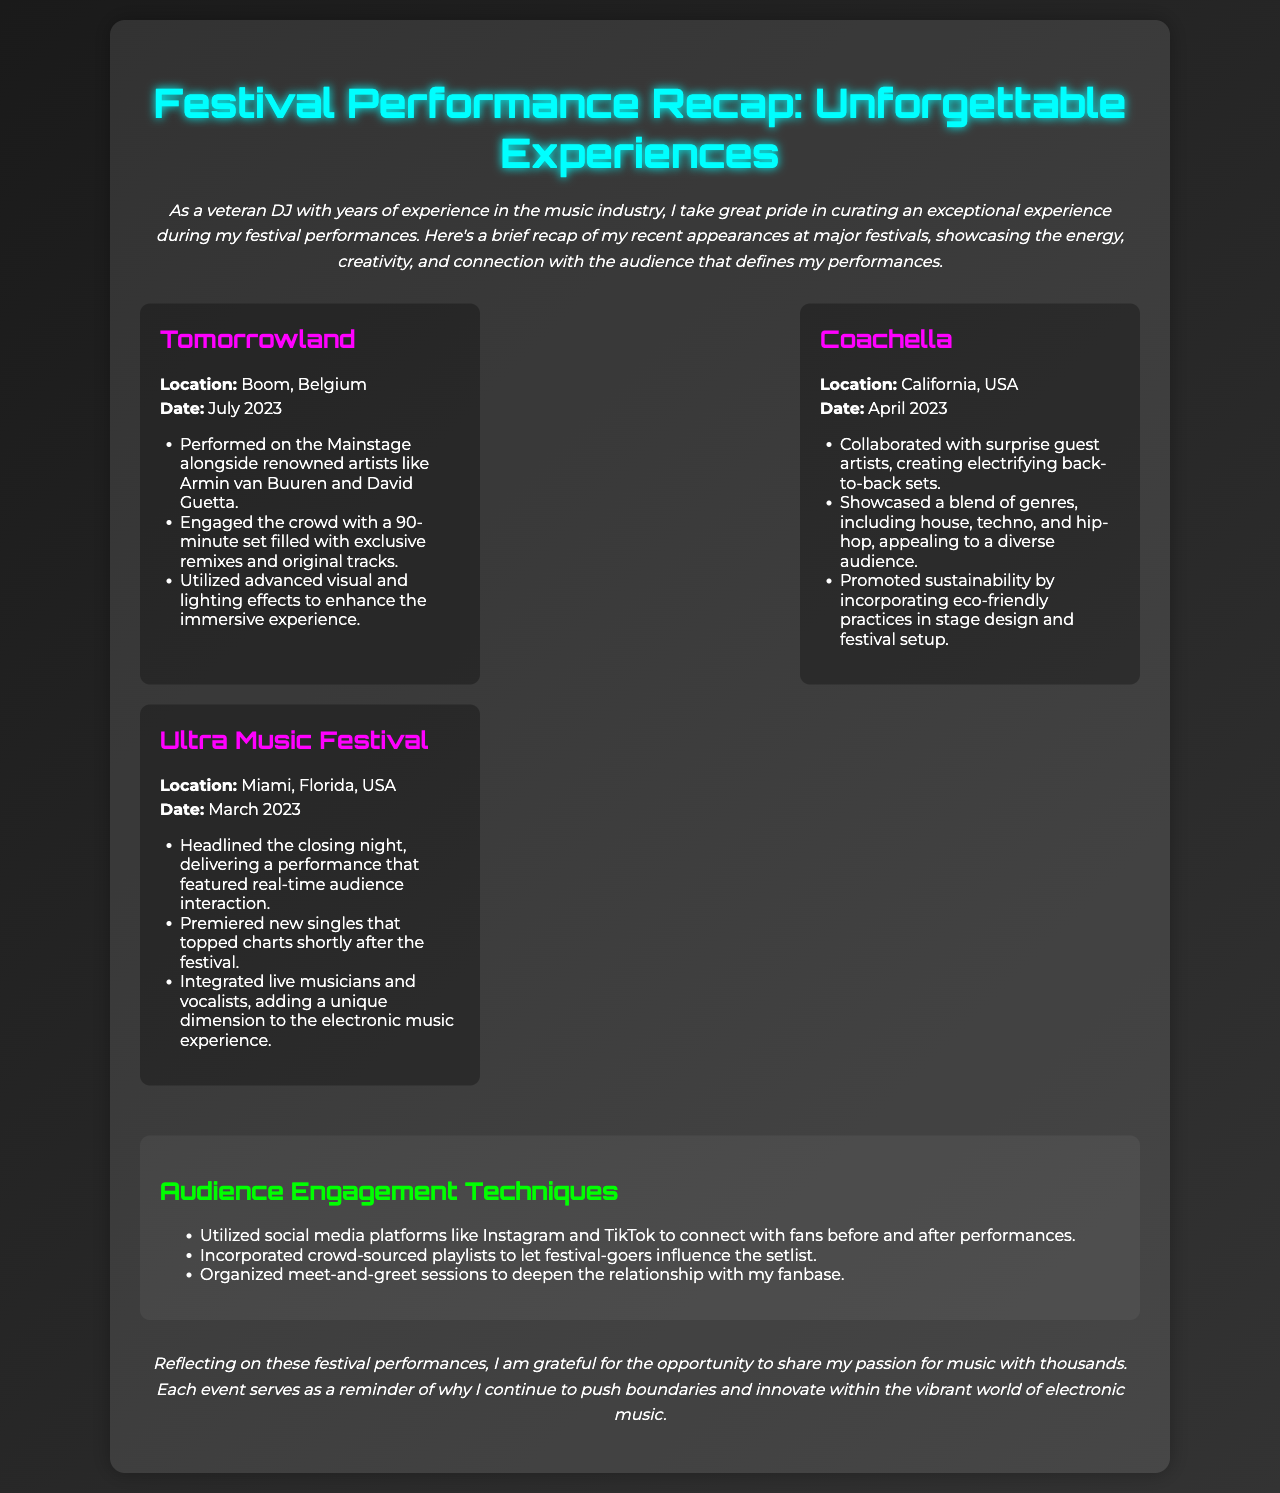What was the location of Tomorrowland? Tomorrowland took place in Boom, Belgium, as stated in the festival details.
Answer: Boom, Belgium When did the Coachella performance occur? The performance at Coachella happened in April 2023, according to the date provided in the festival section.
Answer: April 2023 Who did the DJ perform alongside at Tomorrowland? The document mentions that the DJ performed alongside renowned artists like Armin van Buuren and David Guetta.
Answer: Armin van Buuren and David Guetta What unique feature was highlighted in the Ultra Music Festival performance? The DJ's performance integrated live musicians and vocalists, as described in the Ultra Music Festival details.
Answer: Live musicians and vocalists Which festival showcased a blend of genres, including house and hip-hop? The Coachella festival highlighted a blend of genres, as noted in the performance description.
Answer: Coachella What audience engagement technique involved social media? The DJ utilized social media platforms like Instagram and TikTok to connect with fans, as explained in the audience engagement section.
Answer: Social media platforms How long was the DJ's set at Tomorrowland? The DJ's set at Tomorrowland was a 90-minute performance, according to the recital details.
Answer: 90 minutes What is the main theme of the document? The main theme revolves around the DJ’s festival performances and the unforgettable experiences created.
Answer: Unforgettable experiences What was emphasized about sustainability at Coachella? The document notes that sustainability was promoted by incorporating eco-friendly practices.
Answer: Eco-friendly practices 